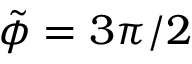Convert formula to latex. <formula><loc_0><loc_0><loc_500><loc_500>\tilde { \phi } = 3 \pi / 2</formula> 